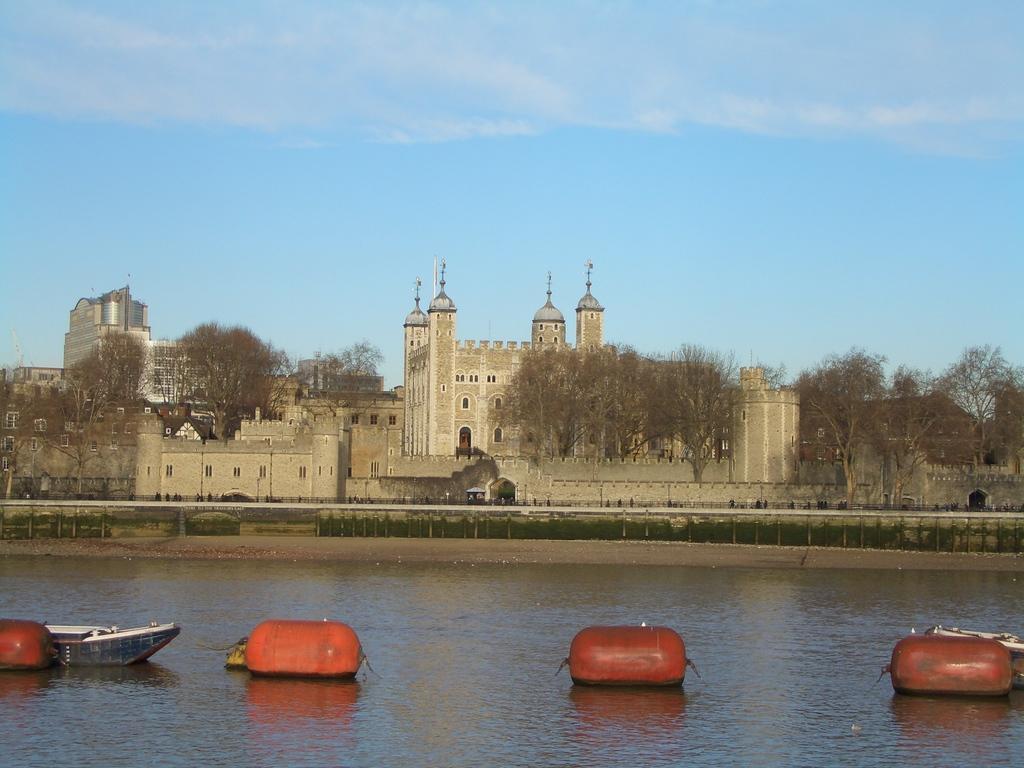How would you summarize this image in a sentence or two? In this image I see the water over here and I see red color things and I see a boat over here. In the background I see the buildings, trees and the clear sky. 